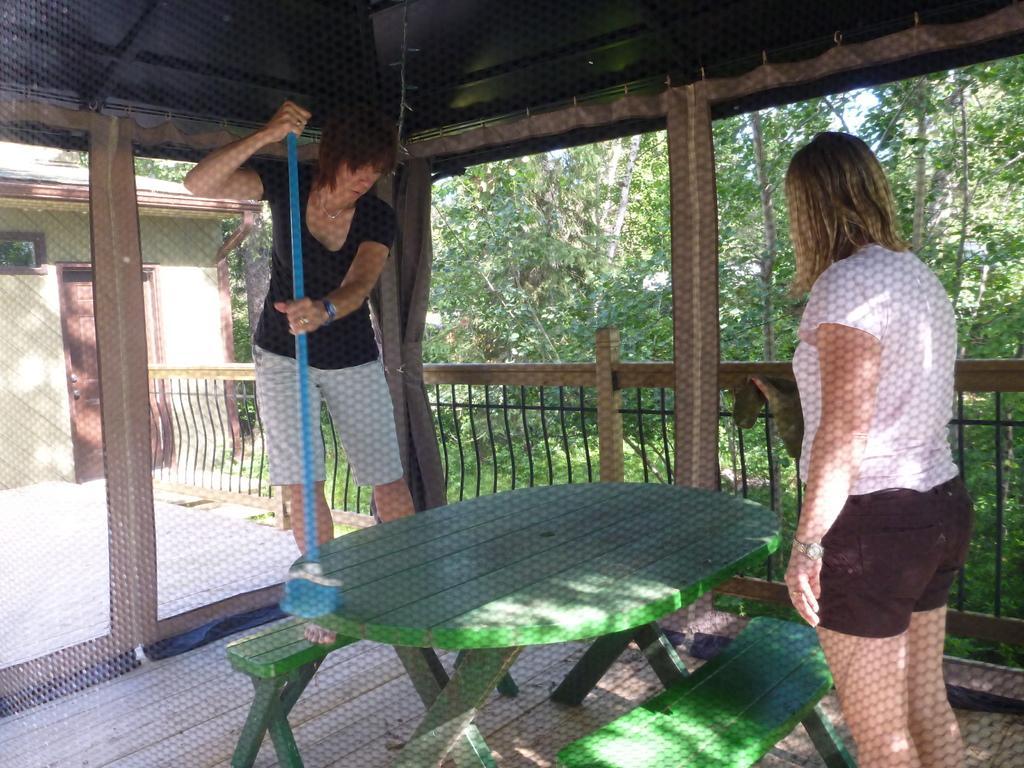In one or two sentences, can you explain what this image depicts? The picture is taken outside the house where one woman is standing in front of the bench and table and one woman is standing on the bench with a stick in her hand and behind them there are trees and house. 